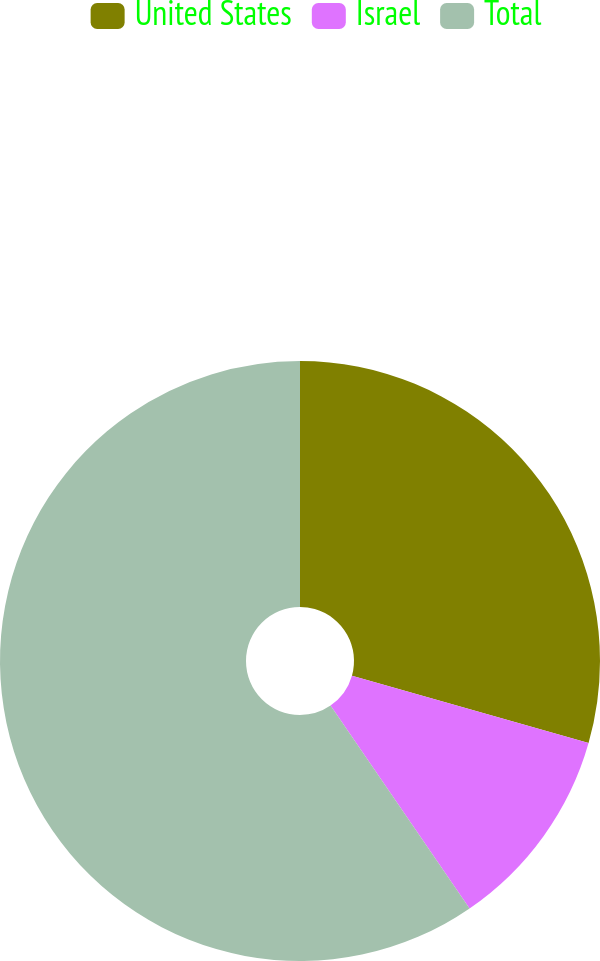Convert chart to OTSL. <chart><loc_0><loc_0><loc_500><loc_500><pie_chart><fcel>United States<fcel>Israel<fcel>Total<nl><fcel>29.41%<fcel>11.03%<fcel>59.56%<nl></chart> 